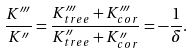<formula> <loc_0><loc_0><loc_500><loc_500>\frac { K ^ { \prime \prime \prime } } { K ^ { \prime \prime } } = \frac { K ^ { \prime \prime \prime } _ { t r e e } + K ^ { \prime \prime \prime } _ { c o r } } { K ^ { \prime \prime } _ { t r e e } + K ^ { \prime \prime } _ { c o r } } = - \frac { 1 } { \delta } .</formula> 